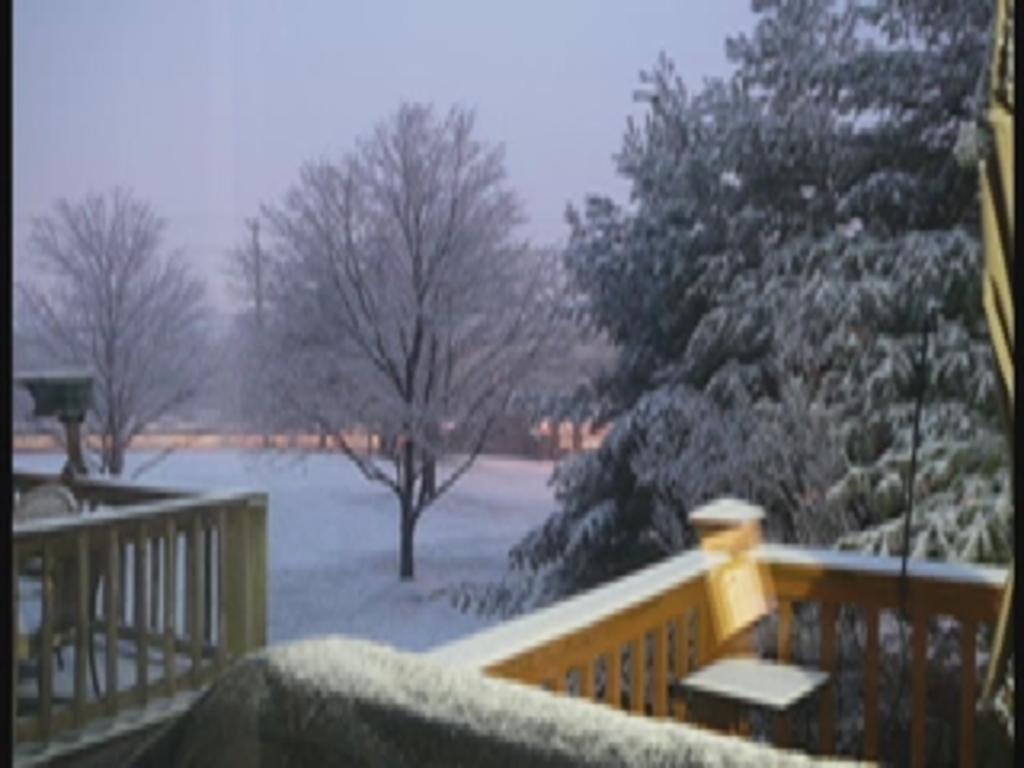What type of vegetation is on the right side of the image? There is a tree on the right side of the image. What type of furniture is on the right side of the image? There is a stool on the right side of the image. What type of barrier is on the right side of the image? There is wooden fencing on the right side of the image. What type of barrier is on the left side of the image? There is wooden fencing on the left side of the image. What type of furniture is on the left side of the image? There is a chair on the left side of the image. What type of vegetation is on the left side of the image? There are trees on the left side of the image. What type of cactus can be seen growing on the left side of the image? There is no cactus present in the image; it features trees and wooden fencing. What effect does the car have on the wooden fencing in the image? There is no car present in the image, so it cannot have any effect on the wooden fencing. 